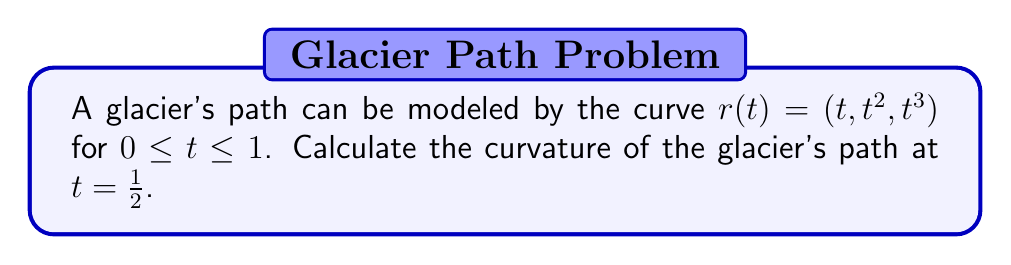Teach me how to tackle this problem. To find the curvature of the glacier's path, we'll use the formula for the curvature of a space curve:

$$\kappa = \frac{|\mathbf{r}'(t) \times \mathbf{r}''(t)|}{|\mathbf{r}'(t)|^3}$$

Let's proceed step by step:

1) First, we need to find $\mathbf{r}'(t)$ and $\mathbf{r}''(t)$:

   $\mathbf{r}'(t) = (1, 2t, 3t^2)$
   $\mathbf{r}''(t) = (0, 2, 6t)$

2) Now, let's calculate the cross product $\mathbf{r}'(t) \times \mathbf{r}''(t)$:

   $\mathbf{r}'(t) \times \mathbf{r}''(t) = (6t^3-6t^2, -6t, 2)$

3) The magnitude of this cross product is:

   $|\mathbf{r}'(t) \times \mathbf{r}''(t)| = \sqrt{(6t^3-6t^2)^2 + (-6t)^2 + 2^2}$

4) Next, we need to calculate $|\mathbf{r}'(t)|^3$:

   $|\mathbf{r}'(t)| = \sqrt{1^2 + (2t)^2 + (3t^2)^2} = \sqrt{1 + 4t^2 + 9t^4}$
   
   $|\mathbf{r}'(t)|^3 = (1 + 4t^2 + 9t^4)^{3/2}$

5) Now, we can write the expression for curvature:

   $$\kappa(t) = \frac{\sqrt{(6t^3-6t^2)^2 + (-6t)^2 + 2^2}}{(1 + 4t^2 + 9t^4)^{3/2}}$$

6) To find the curvature at $t = \frac{1}{2}$, we substitute this value:

   $$\kappa(\frac{1}{2}) = \frac{\sqrt{(\frac{3}{4}-\frac{3}{2})^2 + (-3)^2 + 2^2}}{(1 + 1 + \frac{9}{16})^{3/2}}$$

7) Simplifying:

   $$\kappa(\frac{1}{2}) = \frac{\sqrt{(-\frac{3}{4})^2 + 9 + 4}}{(\frac{41}{16})^{3/2}} = \frac{\sqrt{\frac{9}{16} + 13}}{(\frac{41}{16})^{3/2}} = \frac{4\sqrt{\frac{217}{16}}}{(\frac{41}{16})^{3/2}}$$
Answer: The curvature of the glacier's path at $t = \frac{1}{2}$ is $\frac{4\sqrt{\frac{217}{16}}}{(\frac{41}{16})^{3/2}}$. 